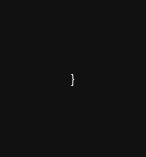Convert code to text. <code><loc_0><loc_0><loc_500><loc_500><_Ceylon_>}</code> 